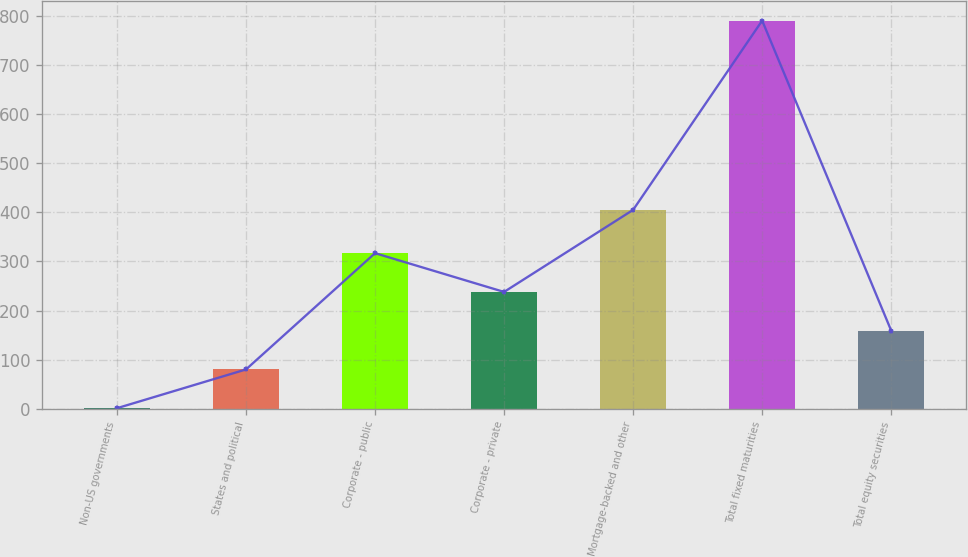Convert chart to OTSL. <chart><loc_0><loc_0><loc_500><loc_500><bar_chart><fcel>Non-US governments<fcel>States and political<fcel>Corporate - public<fcel>Corporate - private<fcel>Mortgage-backed and other<fcel>Total fixed maturities<fcel>Total equity securities<nl><fcel>1.1<fcel>80.05<fcel>316.9<fcel>237.95<fcel>405.1<fcel>790.6<fcel>159<nl></chart> 